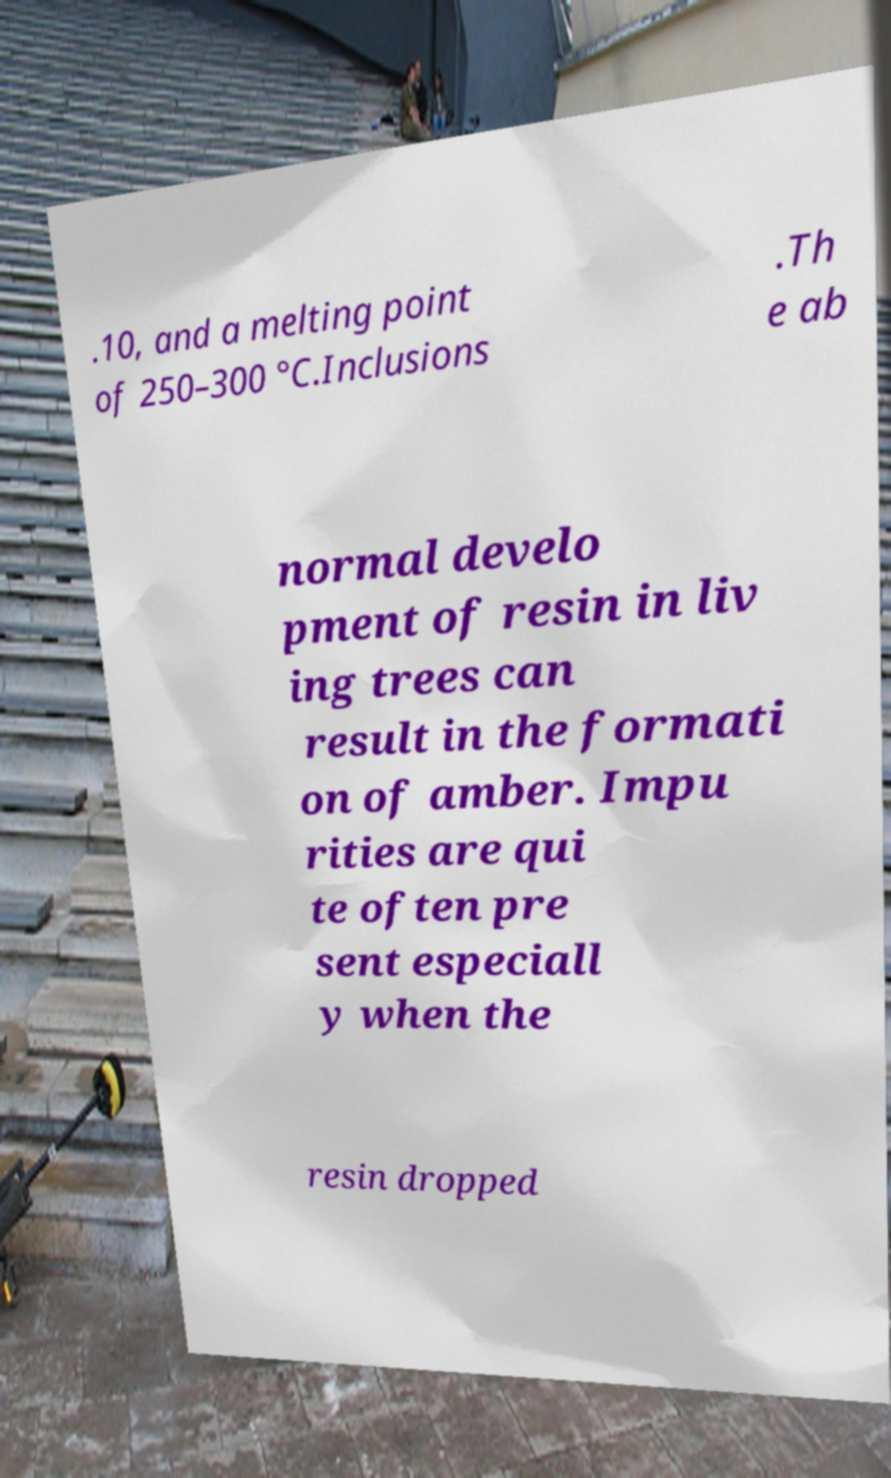Please read and relay the text visible in this image. What does it say? .10, and a melting point of 250–300 °C.Inclusions .Th e ab normal develo pment of resin in liv ing trees can result in the formati on of amber. Impu rities are qui te often pre sent especiall y when the resin dropped 